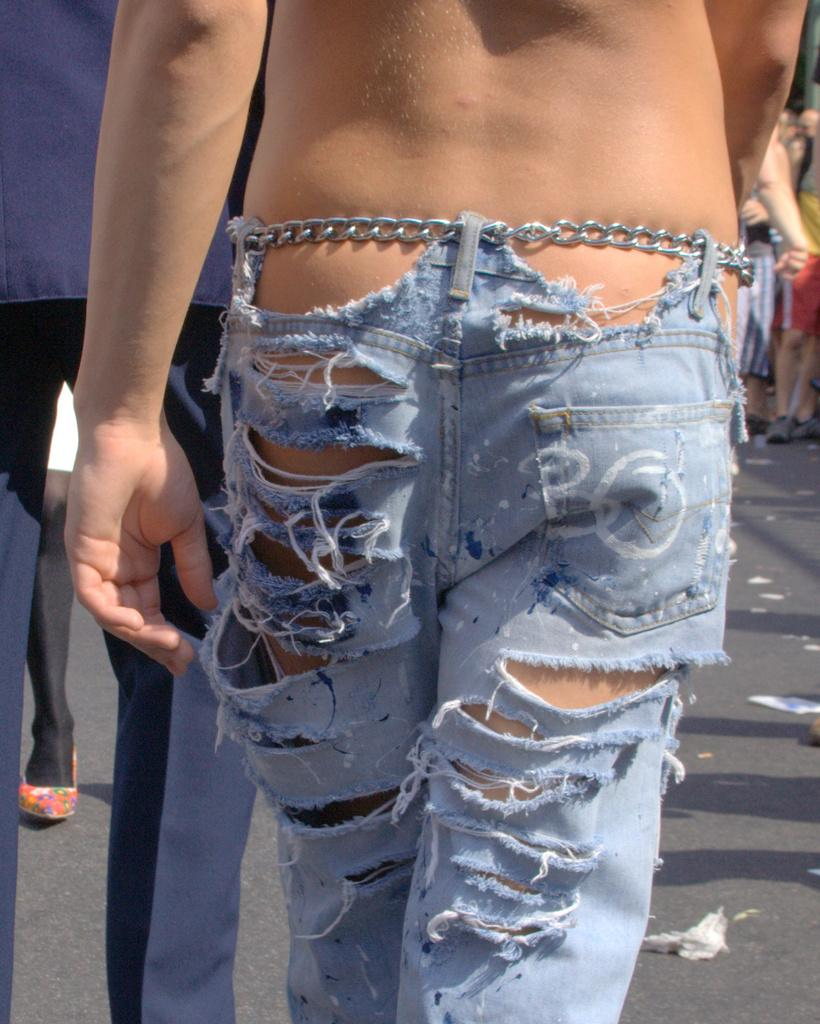Who is present in the image? There is a person in the image. What is the person wearing? The person is wearing torn jeans. What is the person doing in the image? The person is walking on the road. Are there any other people in the image? Yes, there are other people walking in front of the person. What type of rail can be seen in the image? There is no rail present in the image; it features a person walking on the road. Is the person's uncle visible in the image? There is no mention of an uncle in the image, only a person walking on the road. 